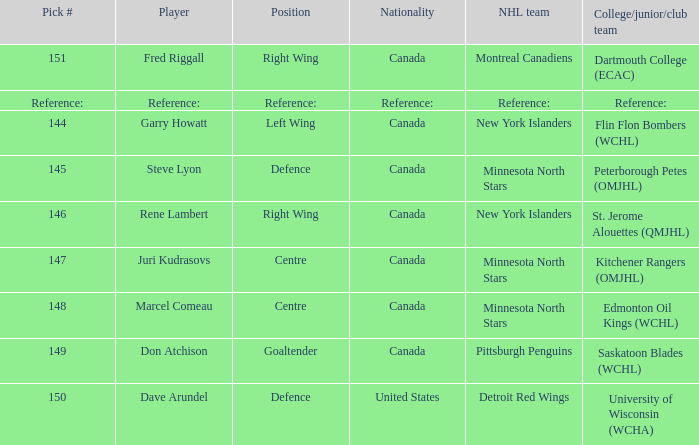Which player(s) was drafted by the Pittsburgh Penguins? Don Atchison. 